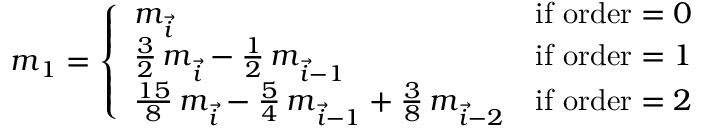<formula> <loc_0><loc_0><loc_500><loc_500>\begin{array} { r } { m _ { 1 } = \left \{ \begin{array} { l l } { m _ { \vec { i } } } & { i f o r d e r = 0 } \\ { \frac { 3 } { 2 } \, m _ { \vec { i } } - \frac { 1 } { 2 } \, m _ { \vec { i } - 1 } } & { i f o r d e r = 1 } \\ { \frac { 1 5 } { 8 } \, m _ { \vec { i } } - \frac { 5 } { 4 } \, m _ { \vec { i } - 1 } + \frac { 3 } { 8 } \, m _ { \vec { i } - 2 } } & { i f o r d e r = 2 } \end{array} } \end{array}</formula> 